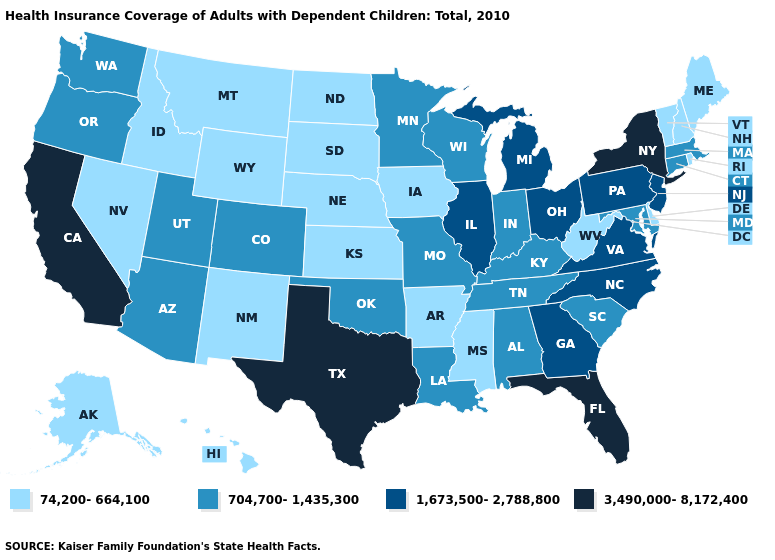Among the states that border Kentucky , does Virginia have the highest value?
Give a very brief answer. Yes. What is the value of New York?
Answer briefly. 3,490,000-8,172,400. What is the highest value in the West ?
Quick response, please. 3,490,000-8,172,400. What is the value of Virginia?
Write a very short answer. 1,673,500-2,788,800. What is the lowest value in the West?
Be succinct. 74,200-664,100. What is the lowest value in the USA?
Give a very brief answer. 74,200-664,100. What is the value of Kentucky?
Answer briefly. 704,700-1,435,300. What is the lowest value in states that border Washington?
Quick response, please. 74,200-664,100. Does New York have the same value as Kansas?
Keep it brief. No. What is the value of Rhode Island?
Short answer required. 74,200-664,100. What is the highest value in the USA?
Answer briefly. 3,490,000-8,172,400. Among the states that border Missouri , which have the lowest value?
Short answer required. Arkansas, Iowa, Kansas, Nebraska. Name the states that have a value in the range 3,490,000-8,172,400?
Short answer required. California, Florida, New York, Texas. Does Delaware have the highest value in the USA?
Answer briefly. No. What is the value of Michigan?
Be succinct. 1,673,500-2,788,800. 